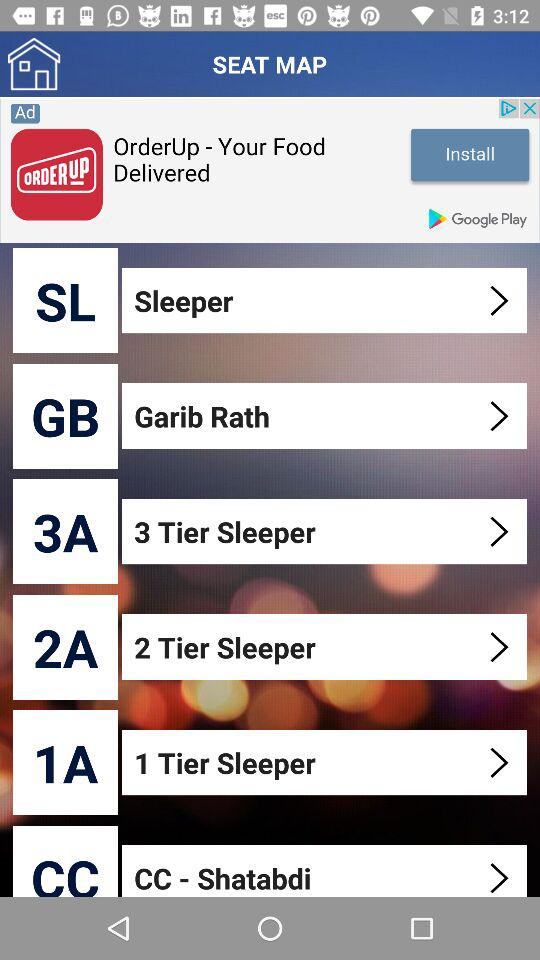What is the short form of "Garib Rath"? The short form of "Garib Rath" is GB. 